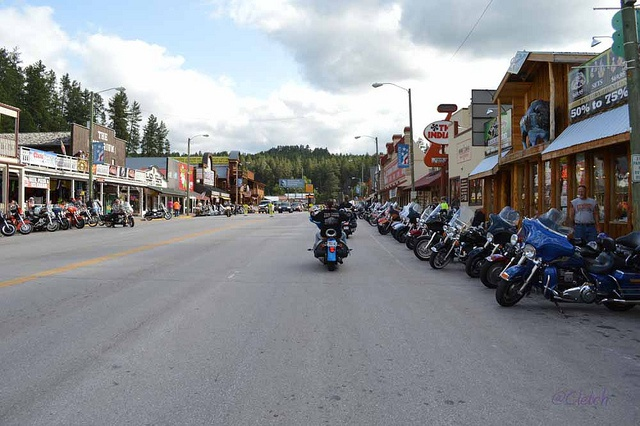Describe the objects in this image and their specific colors. I can see motorcycle in lightblue, black, gray, darkgray, and maroon tones, motorcycle in lightblue, black, navy, gray, and blue tones, motorcycle in lightblue, black, gray, and darkblue tones, motorcycle in lightblue, black, gray, and darkgray tones, and people in lightblue, black, gray, and maroon tones in this image. 